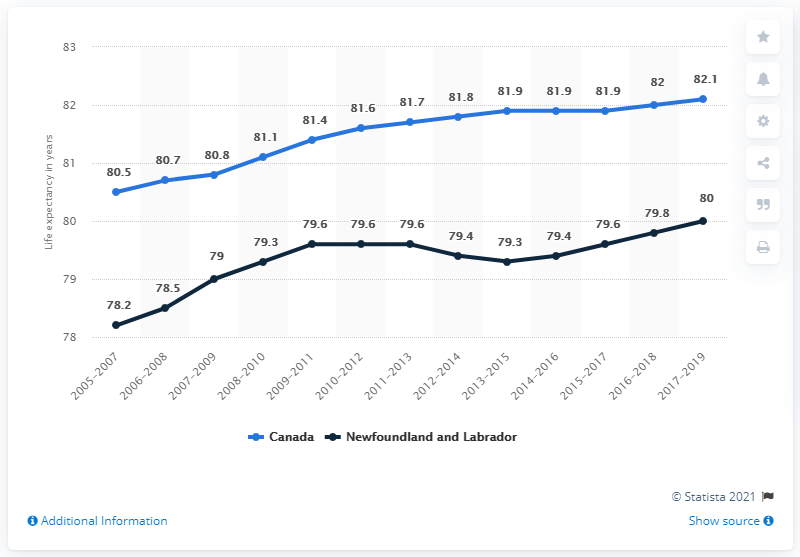Draw attention to some important aspects in this diagram. The sum of the lowest of Canada and Newfoundland and Labrador is 158.7. The maximum life expectancy in Canada is 82.1 years, according to the latest data. 